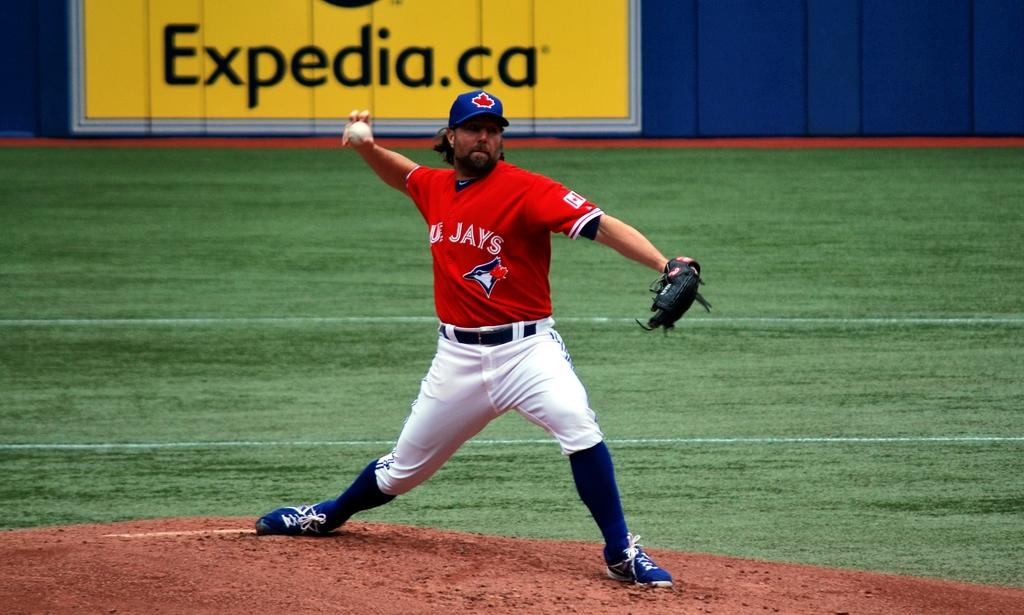Provide a one-sentence caption for the provided image. A baseball player in a red and white uniform for the Blue Jays delivers a pitch. 